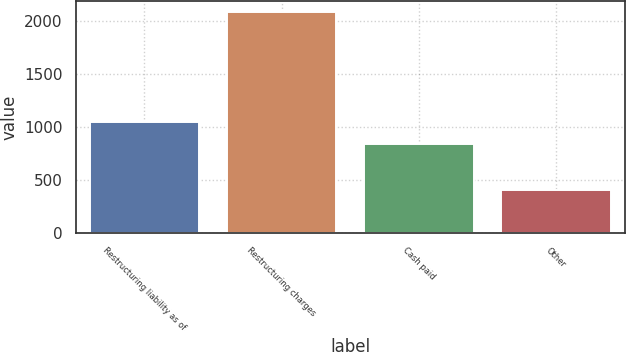<chart> <loc_0><loc_0><loc_500><loc_500><bar_chart><fcel>Restructuring liability as of<fcel>Restructuring charges<fcel>Cash paid<fcel>Other<nl><fcel>1042.54<fcel>2078<fcel>835<fcel>406<nl></chart> 